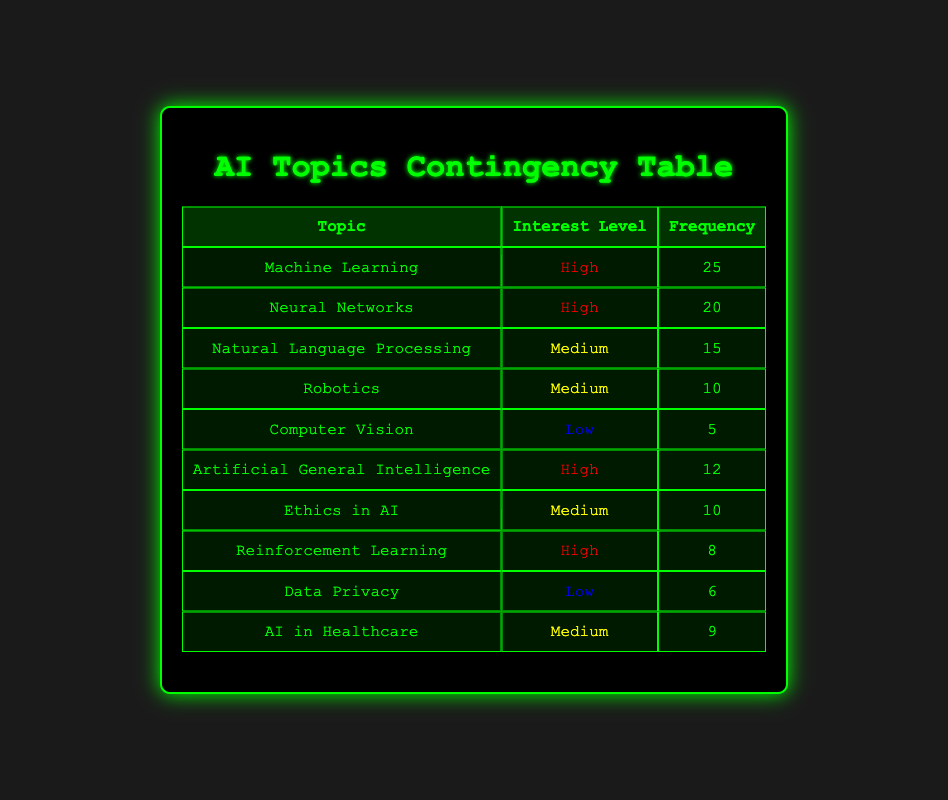What is the frequency of discussions on Machine Learning? The table shows that the frequency of discussions specifically about Machine Learning is listed as 25.
Answer: 25 How many topics are categorized as High interest level? By reviewing the table, there are three topics marked with a high interest level: Machine Learning, Neural Networks, and Artificial General Intelligence.
Answer: 3 What is the combined frequency of topics with a Medium interest level? The topics with a Medium interest level have the following frequencies: Natural Language Processing (15), Robotics (10), Ethics in AI (10), and AI in Healthcare (9). Summing these gives 15 + 10 + 10 + 9 = 44.
Answer: 44 Is there a topic with Low interest level that has a frequency of more than 5? The topics with a Low interest level are Computer Vision (5) and Data Privacy (6). Among them, Data Privacy has a frequency greater than 5, making the statement true.
Answer: Yes Which topic with a High interest level has the lowest frequency? The High interest level topics are: Machine Learning (25), Neural Networks (20), and Artificial General Intelligence (12), and Reinforcement Learning (8). Reinforcement Learning has the lowest frequency among them, which is 8.
Answer: Reinforcement Learning What is the total frequency of all topics discussed? The total frequency can be calculated by summing every frequency value in the table: 25 + 20 + 15 + 10 + 5 + 12 + 10 + 8 + 6 + 9 = 120.
Answer: 120 Are there more topics with Medium interest level than those with Low interest level? The table shows 4 topics labeled as Medium interest level (Natural Language Processing, Robotics, Ethics in AI, AI in Healthcare) and 2 topics categorized as Low interest level (Computer Vision and Data Privacy). Since 4 is greater than 2, the statement is true.
Answer: Yes What is the frequency difference between the highest and the lowest frequency topics? The highest frequency topic is Machine Learning with 25, and the lowest frequency topic is Computer Vision with 5. Subtracting gives 25 - 5 = 20.
Answer: 20 